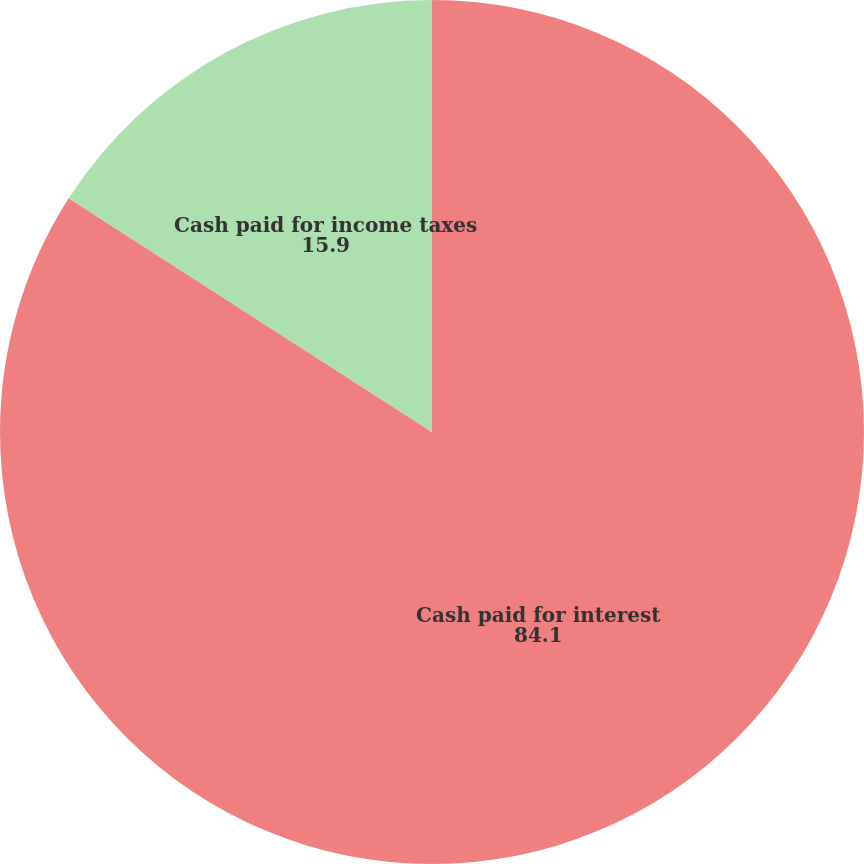Convert chart to OTSL. <chart><loc_0><loc_0><loc_500><loc_500><pie_chart><fcel>Cash paid for interest<fcel>Cash paid for income taxes<nl><fcel>84.1%<fcel>15.9%<nl></chart> 